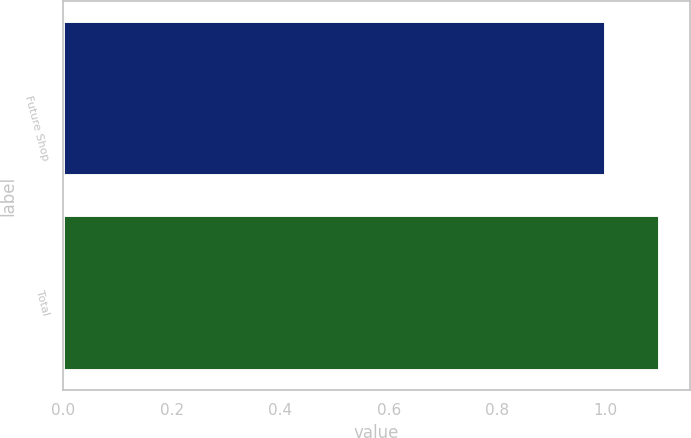Convert chart. <chart><loc_0><loc_0><loc_500><loc_500><bar_chart><fcel>Future Shop<fcel>Total<nl><fcel>1<fcel>1.1<nl></chart> 